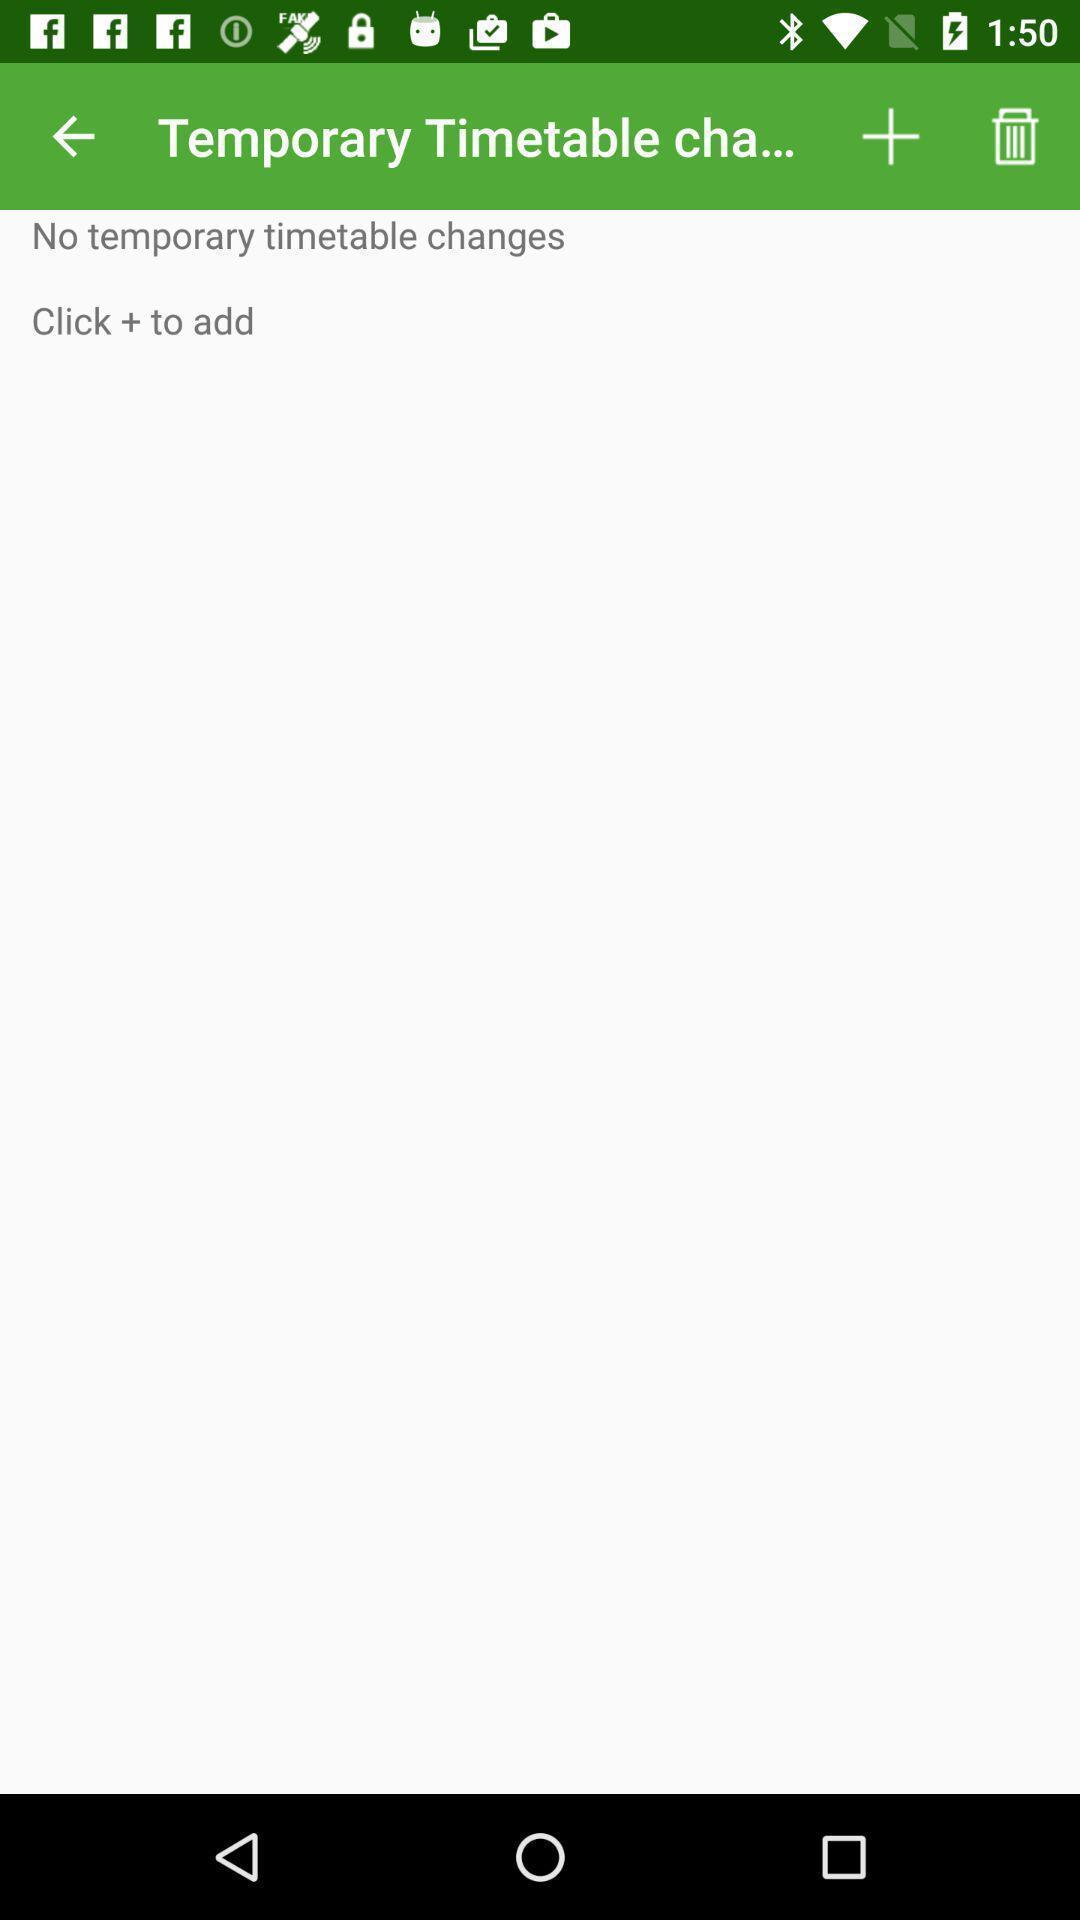Give me a summary of this screen capture. Page displaying the temporary timetable chart. 